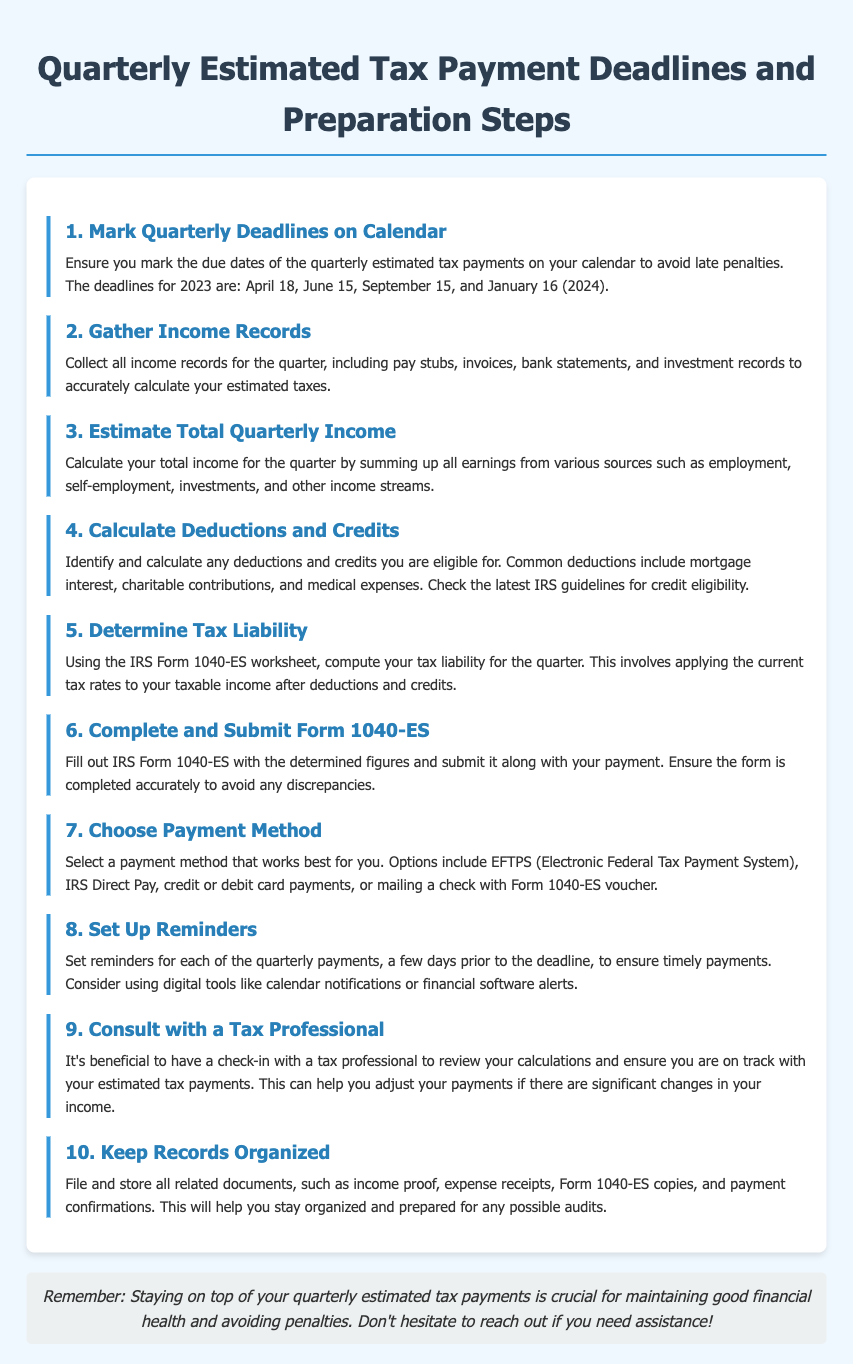What is the first quarterly payment deadline for 2023? The first quarterly payment deadline listed in the document is April 18, 2023.
Answer: April 18 How many payments are due in 2023? The document lists four quarterly estimated tax payments due in 2023.
Answer: Four What form is used to calculate tax liability? The form mentioned for calculating tax liability is IRS Form 1040-ES.
Answer: IRS Form 1040-ES What should be done before completing Form 1040-ES? Before completing Form 1040-ES, you need to calculate your deductions and credits.
Answer: Calculate deductions and credits When should reminders be set for payments? Reminders should be set a few days prior to each quarterly payment deadline.
Answer: A few days prior What is the purpose of consulting with a tax professional? Consulting with a tax professional helps to review calculations and adjust payments if necessary.
Answer: Review calculations and adjust payments What is the suggested payment method? The document suggests using the Electronic Federal Tax Payment System (EFTPS) as a payment method.
Answer: EFTPS What should be kept organized for tax purposes? All related documents, including income proof and payment confirmations, should be kept organized.
Answer: Related documents 